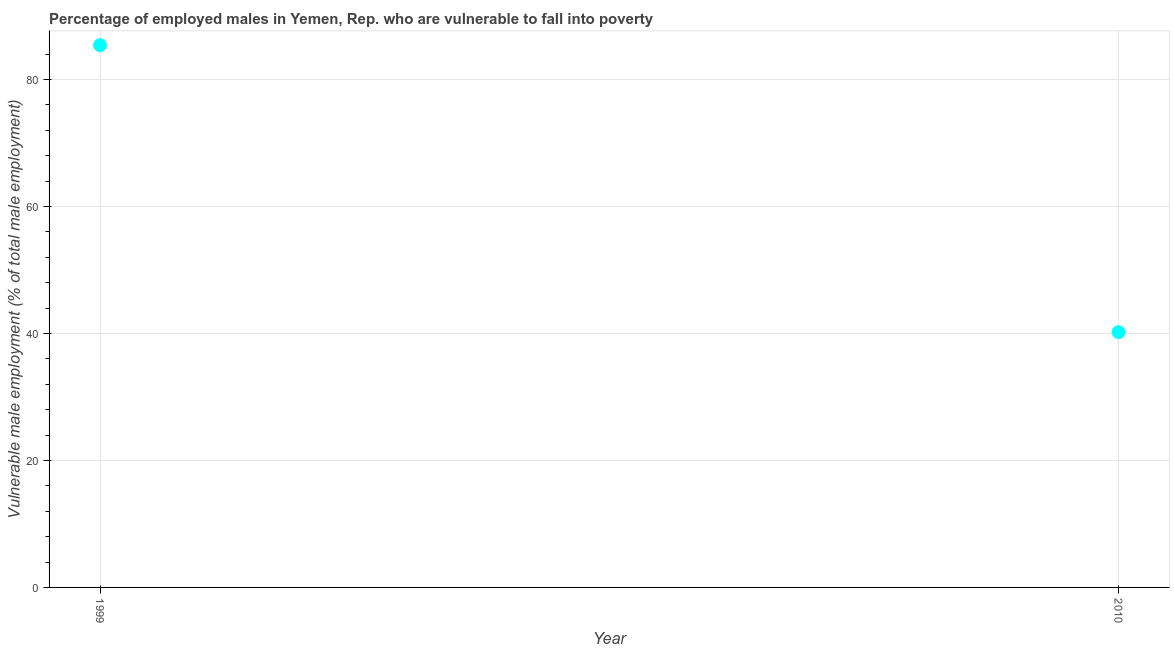What is the percentage of employed males who are vulnerable to fall into poverty in 2010?
Make the answer very short. 40.2. Across all years, what is the maximum percentage of employed males who are vulnerable to fall into poverty?
Give a very brief answer. 85.4. Across all years, what is the minimum percentage of employed males who are vulnerable to fall into poverty?
Offer a terse response. 40.2. In which year was the percentage of employed males who are vulnerable to fall into poverty minimum?
Ensure brevity in your answer.  2010. What is the sum of the percentage of employed males who are vulnerable to fall into poverty?
Provide a succinct answer. 125.6. What is the difference between the percentage of employed males who are vulnerable to fall into poverty in 1999 and 2010?
Offer a very short reply. 45.2. What is the average percentage of employed males who are vulnerable to fall into poverty per year?
Keep it short and to the point. 62.8. What is the median percentage of employed males who are vulnerable to fall into poverty?
Your response must be concise. 62.8. In how many years, is the percentage of employed males who are vulnerable to fall into poverty greater than 36 %?
Provide a succinct answer. 2. Do a majority of the years between 1999 and 2010 (inclusive) have percentage of employed males who are vulnerable to fall into poverty greater than 60 %?
Offer a terse response. No. What is the ratio of the percentage of employed males who are vulnerable to fall into poverty in 1999 to that in 2010?
Provide a short and direct response. 2.12. Is the percentage of employed males who are vulnerable to fall into poverty in 1999 less than that in 2010?
Your answer should be very brief. No. In how many years, is the percentage of employed males who are vulnerable to fall into poverty greater than the average percentage of employed males who are vulnerable to fall into poverty taken over all years?
Your answer should be compact. 1. How many dotlines are there?
Your answer should be very brief. 1. What is the difference between two consecutive major ticks on the Y-axis?
Your response must be concise. 20. Are the values on the major ticks of Y-axis written in scientific E-notation?
Provide a short and direct response. No. What is the title of the graph?
Offer a very short reply. Percentage of employed males in Yemen, Rep. who are vulnerable to fall into poverty. What is the label or title of the Y-axis?
Ensure brevity in your answer.  Vulnerable male employment (% of total male employment). What is the Vulnerable male employment (% of total male employment) in 1999?
Provide a succinct answer. 85.4. What is the Vulnerable male employment (% of total male employment) in 2010?
Keep it short and to the point. 40.2. What is the difference between the Vulnerable male employment (% of total male employment) in 1999 and 2010?
Give a very brief answer. 45.2. What is the ratio of the Vulnerable male employment (% of total male employment) in 1999 to that in 2010?
Make the answer very short. 2.12. 